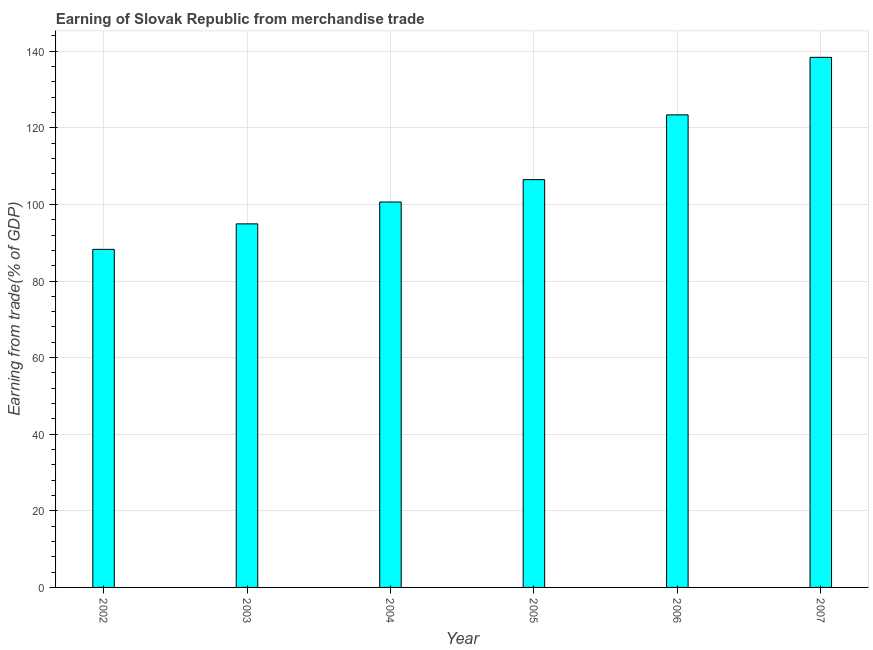Does the graph contain grids?
Ensure brevity in your answer.  Yes. What is the title of the graph?
Ensure brevity in your answer.  Earning of Slovak Republic from merchandise trade. What is the label or title of the X-axis?
Make the answer very short. Year. What is the label or title of the Y-axis?
Provide a short and direct response. Earning from trade(% of GDP). What is the earning from merchandise trade in 2004?
Provide a short and direct response. 100.64. Across all years, what is the maximum earning from merchandise trade?
Your response must be concise. 138.41. Across all years, what is the minimum earning from merchandise trade?
Provide a succinct answer. 88.27. In which year was the earning from merchandise trade minimum?
Keep it short and to the point. 2002. What is the sum of the earning from merchandise trade?
Provide a succinct answer. 652.1. What is the difference between the earning from merchandise trade in 2005 and 2007?
Offer a terse response. -31.93. What is the average earning from merchandise trade per year?
Your response must be concise. 108.68. What is the median earning from merchandise trade?
Provide a short and direct response. 103.56. What is the ratio of the earning from merchandise trade in 2005 to that in 2007?
Your answer should be compact. 0.77. Is the difference between the earning from merchandise trade in 2002 and 2006 greater than the difference between any two years?
Your answer should be compact. No. What is the difference between the highest and the second highest earning from merchandise trade?
Offer a very short reply. 15.03. Is the sum of the earning from merchandise trade in 2003 and 2005 greater than the maximum earning from merchandise trade across all years?
Your answer should be very brief. Yes. What is the difference between the highest and the lowest earning from merchandise trade?
Provide a short and direct response. 50.14. In how many years, is the earning from merchandise trade greater than the average earning from merchandise trade taken over all years?
Provide a short and direct response. 2. Are all the bars in the graph horizontal?
Make the answer very short. No. How many years are there in the graph?
Your response must be concise. 6. Are the values on the major ticks of Y-axis written in scientific E-notation?
Ensure brevity in your answer.  No. What is the Earning from trade(% of GDP) of 2002?
Your response must be concise. 88.27. What is the Earning from trade(% of GDP) of 2003?
Provide a short and direct response. 94.92. What is the Earning from trade(% of GDP) in 2004?
Provide a short and direct response. 100.64. What is the Earning from trade(% of GDP) in 2005?
Give a very brief answer. 106.47. What is the Earning from trade(% of GDP) in 2006?
Provide a short and direct response. 123.38. What is the Earning from trade(% of GDP) of 2007?
Offer a terse response. 138.41. What is the difference between the Earning from trade(% of GDP) in 2002 and 2003?
Ensure brevity in your answer.  -6.65. What is the difference between the Earning from trade(% of GDP) in 2002 and 2004?
Give a very brief answer. -12.37. What is the difference between the Earning from trade(% of GDP) in 2002 and 2005?
Ensure brevity in your answer.  -18.2. What is the difference between the Earning from trade(% of GDP) in 2002 and 2006?
Your answer should be compact. -35.11. What is the difference between the Earning from trade(% of GDP) in 2002 and 2007?
Make the answer very short. -50.14. What is the difference between the Earning from trade(% of GDP) in 2003 and 2004?
Your answer should be compact. -5.71. What is the difference between the Earning from trade(% of GDP) in 2003 and 2005?
Provide a short and direct response. -11.55. What is the difference between the Earning from trade(% of GDP) in 2003 and 2006?
Offer a terse response. -28.46. What is the difference between the Earning from trade(% of GDP) in 2003 and 2007?
Offer a very short reply. -43.48. What is the difference between the Earning from trade(% of GDP) in 2004 and 2005?
Your answer should be very brief. -5.83. What is the difference between the Earning from trade(% of GDP) in 2004 and 2006?
Give a very brief answer. -22.74. What is the difference between the Earning from trade(% of GDP) in 2004 and 2007?
Give a very brief answer. -37.77. What is the difference between the Earning from trade(% of GDP) in 2005 and 2006?
Give a very brief answer. -16.91. What is the difference between the Earning from trade(% of GDP) in 2005 and 2007?
Offer a terse response. -31.94. What is the difference between the Earning from trade(% of GDP) in 2006 and 2007?
Ensure brevity in your answer.  -15.03. What is the ratio of the Earning from trade(% of GDP) in 2002 to that in 2003?
Keep it short and to the point. 0.93. What is the ratio of the Earning from trade(% of GDP) in 2002 to that in 2004?
Provide a short and direct response. 0.88. What is the ratio of the Earning from trade(% of GDP) in 2002 to that in 2005?
Your answer should be compact. 0.83. What is the ratio of the Earning from trade(% of GDP) in 2002 to that in 2006?
Your answer should be compact. 0.71. What is the ratio of the Earning from trade(% of GDP) in 2002 to that in 2007?
Provide a succinct answer. 0.64. What is the ratio of the Earning from trade(% of GDP) in 2003 to that in 2004?
Offer a terse response. 0.94. What is the ratio of the Earning from trade(% of GDP) in 2003 to that in 2005?
Your answer should be compact. 0.89. What is the ratio of the Earning from trade(% of GDP) in 2003 to that in 2006?
Keep it short and to the point. 0.77. What is the ratio of the Earning from trade(% of GDP) in 2003 to that in 2007?
Give a very brief answer. 0.69. What is the ratio of the Earning from trade(% of GDP) in 2004 to that in 2005?
Keep it short and to the point. 0.94. What is the ratio of the Earning from trade(% of GDP) in 2004 to that in 2006?
Provide a short and direct response. 0.82. What is the ratio of the Earning from trade(% of GDP) in 2004 to that in 2007?
Your answer should be very brief. 0.73. What is the ratio of the Earning from trade(% of GDP) in 2005 to that in 2006?
Provide a succinct answer. 0.86. What is the ratio of the Earning from trade(% of GDP) in 2005 to that in 2007?
Your response must be concise. 0.77. What is the ratio of the Earning from trade(% of GDP) in 2006 to that in 2007?
Your response must be concise. 0.89. 